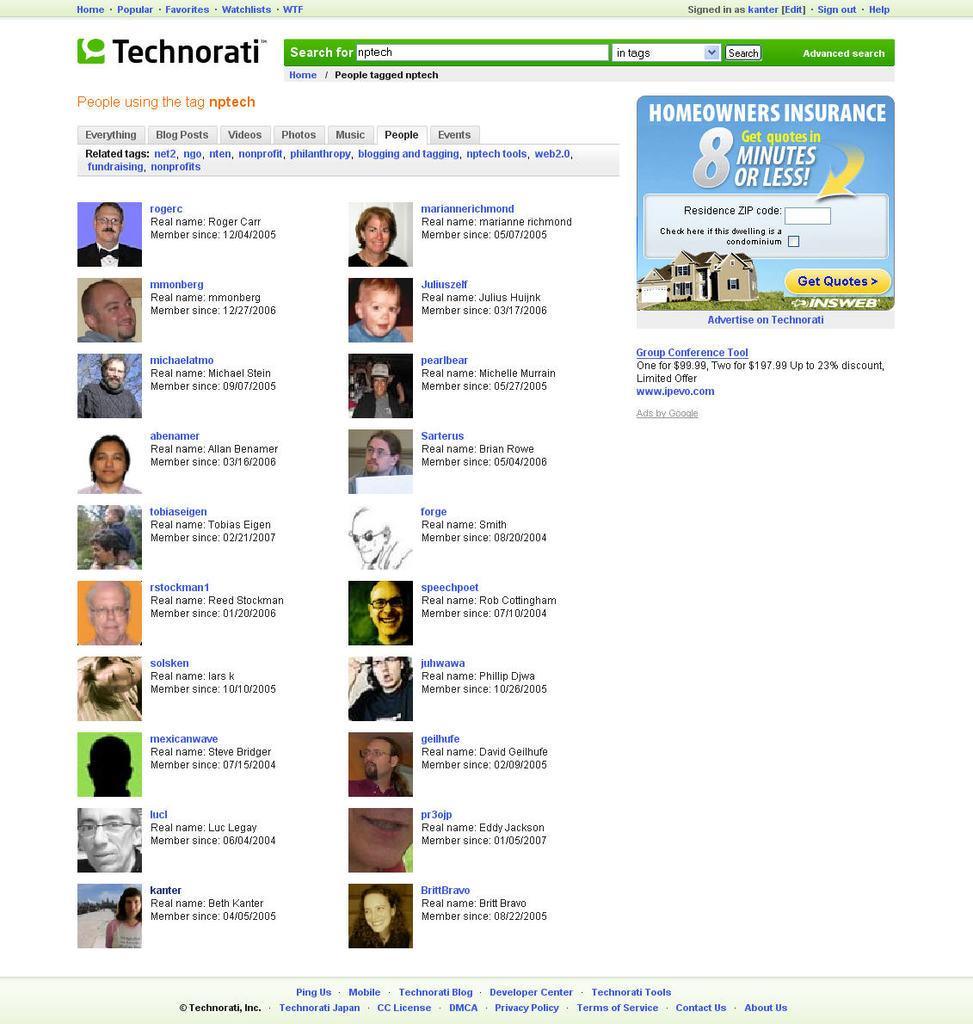In one or two sentences, can you explain what this image depicts? In this image there is text, there are photos of persons, there is a house, the background of the image is white in color. 